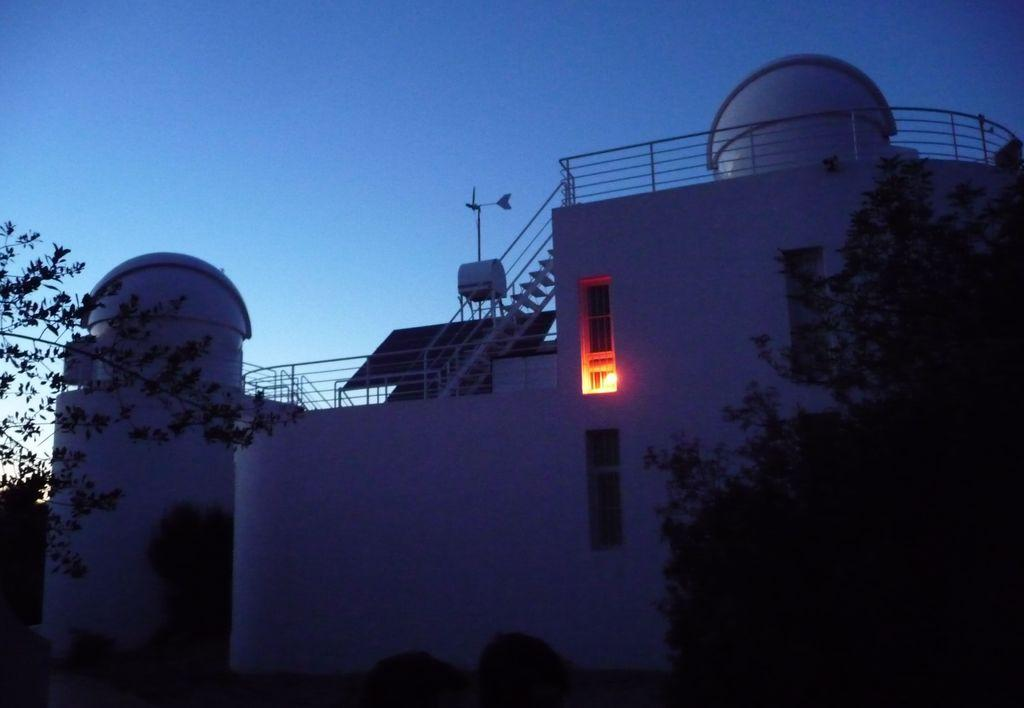What type of vegetation can be seen in the image? There are trees in the image. What is visible in the background of the image? There is a building in the background of the image. What architectural feature is present in the image? There are stairs in the image. What safety feature is present in the image? There is a railing in the image. What can be seen in the building in the image? There are windows in the building. What is the color of the sky in the image? The sky is visible in the background of the image, and it is described as blue. What type of meal is being served on the island in the image? There is no island present in the image, and therefore no meal can be observed. What statement is being made by the trees in the image? The trees in the image are not making any statements; they are simply trees. 